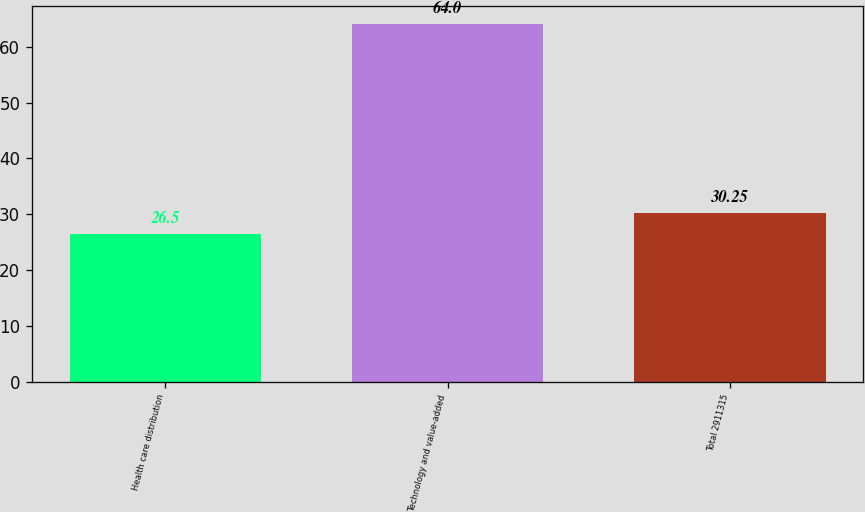<chart> <loc_0><loc_0><loc_500><loc_500><bar_chart><fcel>Health care distribution<fcel>Technology and value-added<fcel>Total 2911315<nl><fcel>26.5<fcel>64<fcel>30.25<nl></chart> 